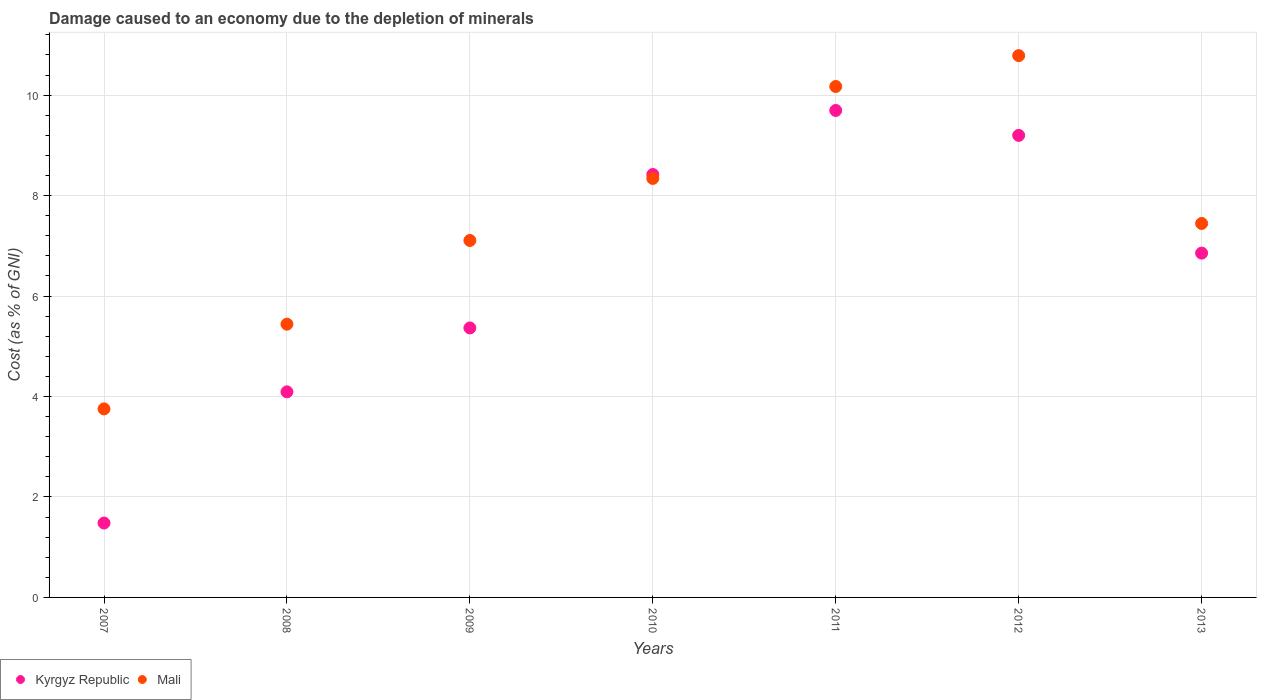How many different coloured dotlines are there?
Offer a very short reply. 2. What is the cost of damage caused due to the depletion of minerals in Mali in 2013?
Make the answer very short. 7.44. Across all years, what is the maximum cost of damage caused due to the depletion of minerals in Kyrgyz Republic?
Give a very brief answer. 9.69. Across all years, what is the minimum cost of damage caused due to the depletion of minerals in Kyrgyz Republic?
Your answer should be compact. 1.48. In which year was the cost of damage caused due to the depletion of minerals in Kyrgyz Republic maximum?
Give a very brief answer. 2011. In which year was the cost of damage caused due to the depletion of minerals in Mali minimum?
Ensure brevity in your answer.  2007. What is the total cost of damage caused due to the depletion of minerals in Kyrgyz Republic in the graph?
Provide a short and direct response. 45.11. What is the difference between the cost of damage caused due to the depletion of minerals in Mali in 2008 and that in 2012?
Give a very brief answer. -5.35. What is the difference between the cost of damage caused due to the depletion of minerals in Kyrgyz Republic in 2009 and the cost of damage caused due to the depletion of minerals in Mali in 2010?
Offer a very short reply. -2.98. What is the average cost of damage caused due to the depletion of minerals in Kyrgyz Republic per year?
Give a very brief answer. 6.44. In the year 2010, what is the difference between the cost of damage caused due to the depletion of minerals in Mali and cost of damage caused due to the depletion of minerals in Kyrgyz Republic?
Offer a terse response. -0.08. What is the ratio of the cost of damage caused due to the depletion of minerals in Mali in 2007 to that in 2013?
Give a very brief answer. 0.5. Is the cost of damage caused due to the depletion of minerals in Kyrgyz Republic in 2010 less than that in 2012?
Keep it short and to the point. Yes. What is the difference between the highest and the second highest cost of damage caused due to the depletion of minerals in Kyrgyz Republic?
Give a very brief answer. 0.5. What is the difference between the highest and the lowest cost of damage caused due to the depletion of minerals in Mali?
Offer a terse response. 7.03. In how many years, is the cost of damage caused due to the depletion of minerals in Kyrgyz Republic greater than the average cost of damage caused due to the depletion of minerals in Kyrgyz Republic taken over all years?
Provide a short and direct response. 4. Is the sum of the cost of damage caused due to the depletion of minerals in Mali in 2008 and 2011 greater than the maximum cost of damage caused due to the depletion of minerals in Kyrgyz Republic across all years?
Your response must be concise. Yes. Does the cost of damage caused due to the depletion of minerals in Kyrgyz Republic monotonically increase over the years?
Provide a succinct answer. No. How many years are there in the graph?
Provide a succinct answer. 7. Does the graph contain grids?
Ensure brevity in your answer.  Yes. What is the title of the graph?
Offer a terse response. Damage caused to an economy due to the depletion of minerals. What is the label or title of the Y-axis?
Keep it short and to the point. Cost (as % of GNI). What is the Cost (as % of GNI) of Kyrgyz Republic in 2007?
Keep it short and to the point. 1.48. What is the Cost (as % of GNI) in Mali in 2007?
Your answer should be very brief. 3.75. What is the Cost (as % of GNI) of Kyrgyz Republic in 2008?
Provide a short and direct response. 4.09. What is the Cost (as % of GNI) of Mali in 2008?
Make the answer very short. 5.44. What is the Cost (as % of GNI) in Kyrgyz Republic in 2009?
Give a very brief answer. 5.37. What is the Cost (as % of GNI) of Mali in 2009?
Provide a short and direct response. 7.11. What is the Cost (as % of GNI) in Kyrgyz Republic in 2010?
Provide a succinct answer. 8.42. What is the Cost (as % of GNI) in Mali in 2010?
Your answer should be compact. 8.34. What is the Cost (as % of GNI) in Kyrgyz Republic in 2011?
Your answer should be very brief. 9.69. What is the Cost (as % of GNI) in Mali in 2011?
Provide a short and direct response. 10.17. What is the Cost (as % of GNI) of Kyrgyz Republic in 2012?
Ensure brevity in your answer.  9.2. What is the Cost (as % of GNI) of Mali in 2012?
Keep it short and to the point. 10.79. What is the Cost (as % of GNI) of Kyrgyz Republic in 2013?
Make the answer very short. 6.85. What is the Cost (as % of GNI) in Mali in 2013?
Your answer should be compact. 7.44. Across all years, what is the maximum Cost (as % of GNI) in Kyrgyz Republic?
Your answer should be compact. 9.69. Across all years, what is the maximum Cost (as % of GNI) of Mali?
Give a very brief answer. 10.79. Across all years, what is the minimum Cost (as % of GNI) in Kyrgyz Republic?
Your answer should be compact. 1.48. Across all years, what is the minimum Cost (as % of GNI) of Mali?
Your answer should be compact. 3.75. What is the total Cost (as % of GNI) in Kyrgyz Republic in the graph?
Provide a short and direct response. 45.11. What is the total Cost (as % of GNI) of Mali in the graph?
Ensure brevity in your answer.  53.04. What is the difference between the Cost (as % of GNI) in Kyrgyz Republic in 2007 and that in 2008?
Provide a succinct answer. -2.61. What is the difference between the Cost (as % of GNI) in Mali in 2007 and that in 2008?
Provide a short and direct response. -1.69. What is the difference between the Cost (as % of GNI) in Kyrgyz Republic in 2007 and that in 2009?
Your answer should be compact. -3.88. What is the difference between the Cost (as % of GNI) of Mali in 2007 and that in 2009?
Give a very brief answer. -3.35. What is the difference between the Cost (as % of GNI) of Kyrgyz Republic in 2007 and that in 2010?
Provide a short and direct response. -6.94. What is the difference between the Cost (as % of GNI) in Mali in 2007 and that in 2010?
Your answer should be very brief. -4.59. What is the difference between the Cost (as % of GNI) in Kyrgyz Republic in 2007 and that in 2011?
Provide a short and direct response. -8.21. What is the difference between the Cost (as % of GNI) of Mali in 2007 and that in 2011?
Make the answer very short. -6.42. What is the difference between the Cost (as % of GNI) in Kyrgyz Republic in 2007 and that in 2012?
Provide a short and direct response. -7.72. What is the difference between the Cost (as % of GNI) in Mali in 2007 and that in 2012?
Offer a very short reply. -7.03. What is the difference between the Cost (as % of GNI) of Kyrgyz Republic in 2007 and that in 2013?
Offer a terse response. -5.37. What is the difference between the Cost (as % of GNI) in Mali in 2007 and that in 2013?
Ensure brevity in your answer.  -3.69. What is the difference between the Cost (as % of GNI) of Kyrgyz Republic in 2008 and that in 2009?
Your response must be concise. -1.27. What is the difference between the Cost (as % of GNI) of Mali in 2008 and that in 2009?
Your response must be concise. -1.67. What is the difference between the Cost (as % of GNI) in Kyrgyz Republic in 2008 and that in 2010?
Keep it short and to the point. -4.33. What is the difference between the Cost (as % of GNI) in Mali in 2008 and that in 2010?
Keep it short and to the point. -2.9. What is the difference between the Cost (as % of GNI) of Kyrgyz Republic in 2008 and that in 2011?
Ensure brevity in your answer.  -5.6. What is the difference between the Cost (as % of GNI) of Mali in 2008 and that in 2011?
Provide a succinct answer. -4.73. What is the difference between the Cost (as % of GNI) of Kyrgyz Republic in 2008 and that in 2012?
Your answer should be compact. -5.11. What is the difference between the Cost (as % of GNI) of Mali in 2008 and that in 2012?
Offer a very short reply. -5.35. What is the difference between the Cost (as % of GNI) in Kyrgyz Republic in 2008 and that in 2013?
Provide a short and direct response. -2.76. What is the difference between the Cost (as % of GNI) in Mali in 2008 and that in 2013?
Make the answer very short. -2. What is the difference between the Cost (as % of GNI) of Kyrgyz Republic in 2009 and that in 2010?
Offer a very short reply. -3.05. What is the difference between the Cost (as % of GNI) of Mali in 2009 and that in 2010?
Ensure brevity in your answer.  -1.24. What is the difference between the Cost (as % of GNI) in Kyrgyz Republic in 2009 and that in 2011?
Your response must be concise. -4.33. What is the difference between the Cost (as % of GNI) in Mali in 2009 and that in 2011?
Provide a short and direct response. -3.07. What is the difference between the Cost (as % of GNI) in Kyrgyz Republic in 2009 and that in 2012?
Your answer should be very brief. -3.83. What is the difference between the Cost (as % of GNI) in Mali in 2009 and that in 2012?
Give a very brief answer. -3.68. What is the difference between the Cost (as % of GNI) in Kyrgyz Republic in 2009 and that in 2013?
Make the answer very short. -1.49. What is the difference between the Cost (as % of GNI) in Mali in 2009 and that in 2013?
Keep it short and to the point. -0.34. What is the difference between the Cost (as % of GNI) of Kyrgyz Republic in 2010 and that in 2011?
Make the answer very short. -1.27. What is the difference between the Cost (as % of GNI) of Mali in 2010 and that in 2011?
Your response must be concise. -1.83. What is the difference between the Cost (as % of GNI) of Kyrgyz Republic in 2010 and that in 2012?
Offer a very short reply. -0.78. What is the difference between the Cost (as % of GNI) of Mali in 2010 and that in 2012?
Provide a succinct answer. -2.44. What is the difference between the Cost (as % of GNI) of Kyrgyz Republic in 2010 and that in 2013?
Your answer should be compact. 1.57. What is the difference between the Cost (as % of GNI) in Mali in 2010 and that in 2013?
Offer a terse response. 0.9. What is the difference between the Cost (as % of GNI) in Kyrgyz Republic in 2011 and that in 2012?
Your answer should be compact. 0.5. What is the difference between the Cost (as % of GNI) in Mali in 2011 and that in 2012?
Offer a very short reply. -0.61. What is the difference between the Cost (as % of GNI) of Kyrgyz Republic in 2011 and that in 2013?
Provide a short and direct response. 2.84. What is the difference between the Cost (as % of GNI) in Mali in 2011 and that in 2013?
Offer a very short reply. 2.73. What is the difference between the Cost (as % of GNI) of Kyrgyz Republic in 2012 and that in 2013?
Your answer should be very brief. 2.34. What is the difference between the Cost (as % of GNI) in Mali in 2012 and that in 2013?
Keep it short and to the point. 3.34. What is the difference between the Cost (as % of GNI) in Kyrgyz Republic in 2007 and the Cost (as % of GNI) in Mali in 2008?
Your answer should be compact. -3.96. What is the difference between the Cost (as % of GNI) in Kyrgyz Republic in 2007 and the Cost (as % of GNI) in Mali in 2009?
Offer a very short reply. -5.63. What is the difference between the Cost (as % of GNI) of Kyrgyz Republic in 2007 and the Cost (as % of GNI) of Mali in 2010?
Your answer should be very brief. -6.86. What is the difference between the Cost (as % of GNI) of Kyrgyz Republic in 2007 and the Cost (as % of GNI) of Mali in 2011?
Give a very brief answer. -8.69. What is the difference between the Cost (as % of GNI) in Kyrgyz Republic in 2007 and the Cost (as % of GNI) in Mali in 2012?
Ensure brevity in your answer.  -9.3. What is the difference between the Cost (as % of GNI) of Kyrgyz Republic in 2007 and the Cost (as % of GNI) of Mali in 2013?
Provide a short and direct response. -5.96. What is the difference between the Cost (as % of GNI) of Kyrgyz Republic in 2008 and the Cost (as % of GNI) of Mali in 2009?
Make the answer very short. -3.01. What is the difference between the Cost (as % of GNI) in Kyrgyz Republic in 2008 and the Cost (as % of GNI) in Mali in 2010?
Provide a short and direct response. -4.25. What is the difference between the Cost (as % of GNI) of Kyrgyz Republic in 2008 and the Cost (as % of GNI) of Mali in 2011?
Offer a very short reply. -6.08. What is the difference between the Cost (as % of GNI) in Kyrgyz Republic in 2008 and the Cost (as % of GNI) in Mali in 2012?
Make the answer very short. -6.69. What is the difference between the Cost (as % of GNI) of Kyrgyz Republic in 2008 and the Cost (as % of GNI) of Mali in 2013?
Your answer should be very brief. -3.35. What is the difference between the Cost (as % of GNI) of Kyrgyz Republic in 2009 and the Cost (as % of GNI) of Mali in 2010?
Make the answer very short. -2.98. What is the difference between the Cost (as % of GNI) of Kyrgyz Republic in 2009 and the Cost (as % of GNI) of Mali in 2011?
Your answer should be compact. -4.81. What is the difference between the Cost (as % of GNI) of Kyrgyz Republic in 2009 and the Cost (as % of GNI) of Mali in 2012?
Make the answer very short. -5.42. What is the difference between the Cost (as % of GNI) in Kyrgyz Republic in 2009 and the Cost (as % of GNI) in Mali in 2013?
Offer a terse response. -2.08. What is the difference between the Cost (as % of GNI) of Kyrgyz Republic in 2010 and the Cost (as % of GNI) of Mali in 2011?
Your answer should be compact. -1.75. What is the difference between the Cost (as % of GNI) of Kyrgyz Republic in 2010 and the Cost (as % of GNI) of Mali in 2012?
Keep it short and to the point. -2.37. What is the difference between the Cost (as % of GNI) of Kyrgyz Republic in 2010 and the Cost (as % of GNI) of Mali in 2013?
Give a very brief answer. 0.97. What is the difference between the Cost (as % of GNI) in Kyrgyz Republic in 2011 and the Cost (as % of GNI) in Mali in 2012?
Provide a succinct answer. -1.09. What is the difference between the Cost (as % of GNI) in Kyrgyz Republic in 2011 and the Cost (as % of GNI) in Mali in 2013?
Give a very brief answer. 2.25. What is the difference between the Cost (as % of GNI) of Kyrgyz Republic in 2012 and the Cost (as % of GNI) of Mali in 2013?
Provide a succinct answer. 1.75. What is the average Cost (as % of GNI) of Kyrgyz Republic per year?
Your answer should be compact. 6.44. What is the average Cost (as % of GNI) of Mali per year?
Your answer should be very brief. 7.58. In the year 2007, what is the difference between the Cost (as % of GNI) of Kyrgyz Republic and Cost (as % of GNI) of Mali?
Your answer should be compact. -2.27. In the year 2008, what is the difference between the Cost (as % of GNI) in Kyrgyz Republic and Cost (as % of GNI) in Mali?
Offer a terse response. -1.35. In the year 2009, what is the difference between the Cost (as % of GNI) in Kyrgyz Republic and Cost (as % of GNI) in Mali?
Give a very brief answer. -1.74. In the year 2010, what is the difference between the Cost (as % of GNI) in Kyrgyz Republic and Cost (as % of GNI) in Mali?
Your response must be concise. 0.08. In the year 2011, what is the difference between the Cost (as % of GNI) of Kyrgyz Republic and Cost (as % of GNI) of Mali?
Keep it short and to the point. -0.48. In the year 2012, what is the difference between the Cost (as % of GNI) in Kyrgyz Republic and Cost (as % of GNI) in Mali?
Ensure brevity in your answer.  -1.59. In the year 2013, what is the difference between the Cost (as % of GNI) of Kyrgyz Republic and Cost (as % of GNI) of Mali?
Make the answer very short. -0.59. What is the ratio of the Cost (as % of GNI) in Kyrgyz Republic in 2007 to that in 2008?
Ensure brevity in your answer.  0.36. What is the ratio of the Cost (as % of GNI) in Mali in 2007 to that in 2008?
Offer a very short reply. 0.69. What is the ratio of the Cost (as % of GNI) of Kyrgyz Republic in 2007 to that in 2009?
Give a very brief answer. 0.28. What is the ratio of the Cost (as % of GNI) of Mali in 2007 to that in 2009?
Make the answer very short. 0.53. What is the ratio of the Cost (as % of GNI) in Kyrgyz Republic in 2007 to that in 2010?
Ensure brevity in your answer.  0.18. What is the ratio of the Cost (as % of GNI) of Mali in 2007 to that in 2010?
Your response must be concise. 0.45. What is the ratio of the Cost (as % of GNI) in Kyrgyz Republic in 2007 to that in 2011?
Offer a very short reply. 0.15. What is the ratio of the Cost (as % of GNI) of Mali in 2007 to that in 2011?
Give a very brief answer. 0.37. What is the ratio of the Cost (as % of GNI) in Kyrgyz Republic in 2007 to that in 2012?
Your answer should be compact. 0.16. What is the ratio of the Cost (as % of GNI) in Mali in 2007 to that in 2012?
Offer a very short reply. 0.35. What is the ratio of the Cost (as % of GNI) of Kyrgyz Republic in 2007 to that in 2013?
Ensure brevity in your answer.  0.22. What is the ratio of the Cost (as % of GNI) of Mali in 2007 to that in 2013?
Offer a very short reply. 0.5. What is the ratio of the Cost (as % of GNI) of Kyrgyz Republic in 2008 to that in 2009?
Ensure brevity in your answer.  0.76. What is the ratio of the Cost (as % of GNI) of Mali in 2008 to that in 2009?
Provide a succinct answer. 0.77. What is the ratio of the Cost (as % of GNI) of Kyrgyz Republic in 2008 to that in 2010?
Give a very brief answer. 0.49. What is the ratio of the Cost (as % of GNI) in Mali in 2008 to that in 2010?
Your answer should be compact. 0.65. What is the ratio of the Cost (as % of GNI) in Kyrgyz Republic in 2008 to that in 2011?
Your answer should be compact. 0.42. What is the ratio of the Cost (as % of GNI) of Mali in 2008 to that in 2011?
Make the answer very short. 0.53. What is the ratio of the Cost (as % of GNI) in Kyrgyz Republic in 2008 to that in 2012?
Provide a short and direct response. 0.44. What is the ratio of the Cost (as % of GNI) in Mali in 2008 to that in 2012?
Your response must be concise. 0.5. What is the ratio of the Cost (as % of GNI) in Kyrgyz Republic in 2008 to that in 2013?
Your answer should be compact. 0.6. What is the ratio of the Cost (as % of GNI) of Mali in 2008 to that in 2013?
Keep it short and to the point. 0.73. What is the ratio of the Cost (as % of GNI) in Kyrgyz Republic in 2009 to that in 2010?
Your answer should be compact. 0.64. What is the ratio of the Cost (as % of GNI) in Mali in 2009 to that in 2010?
Ensure brevity in your answer.  0.85. What is the ratio of the Cost (as % of GNI) of Kyrgyz Republic in 2009 to that in 2011?
Provide a short and direct response. 0.55. What is the ratio of the Cost (as % of GNI) in Mali in 2009 to that in 2011?
Your response must be concise. 0.7. What is the ratio of the Cost (as % of GNI) in Kyrgyz Republic in 2009 to that in 2012?
Offer a terse response. 0.58. What is the ratio of the Cost (as % of GNI) in Mali in 2009 to that in 2012?
Provide a short and direct response. 0.66. What is the ratio of the Cost (as % of GNI) in Kyrgyz Republic in 2009 to that in 2013?
Provide a succinct answer. 0.78. What is the ratio of the Cost (as % of GNI) of Mali in 2009 to that in 2013?
Make the answer very short. 0.95. What is the ratio of the Cost (as % of GNI) in Kyrgyz Republic in 2010 to that in 2011?
Offer a very short reply. 0.87. What is the ratio of the Cost (as % of GNI) in Mali in 2010 to that in 2011?
Offer a terse response. 0.82. What is the ratio of the Cost (as % of GNI) in Kyrgyz Republic in 2010 to that in 2012?
Provide a succinct answer. 0.92. What is the ratio of the Cost (as % of GNI) in Mali in 2010 to that in 2012?
Make the answer very short. 0.77. What is the ratio of the Cost (as % of GNI) in Kyrgyz Republic in 2010 to that in 2013?
Offer a terse response. 1.23. What is the ratio of the Cost (as % of GNI) of Mali in 2010 to that in 2013?
Provide a short and direct response. 1.12. What is the ratio of the Cost (as % of GNI) in Kyrgyz Republic in 2011 to that in 2012?
Make the answer very short. 1.05. What is the ratio of the Cost (as % of GNI) in Mali in 2011 to that in 2012?
Keep it short and to the point. 0.94. What is the ratio of the Cost (as % of GNI) in Kyrgyz Republic in 2011 to that in 2013?
Make the answer very short. 1.41. What is the ratio of the Cost (as % of GNI) in Mali in 2011 to that in 2013?
Provide a succinct answer. 1.37. What is the ratio of the Cost (as % of GNI) of Kyrgyz Republic in 2012 to that in 2013?
Offer a very short reply. 1.34. What is the ratio of the Cost (as % of GNI) in Mali in 2012 to that in 2013?
Your answer should be very brief. 1.45. What is the difference between the highest and the second highest Cost (as % of GNI) of Kyrgyz Republic?
Provide a short and direct response. 0.5. What is the difference between the highest and the second highest Cost (as % of GNI) in Mali?
Give a very brief answer. 0.61. What is the difference between the highest and the lowest Cost (as % of GNI) in Kyrgyz Republic?
Your answer should be very brief. 8.21. What is the difference between the highest and the lowest Cost (as % of GNI) of Mali?
Provide a short and direct response. 7.03. 